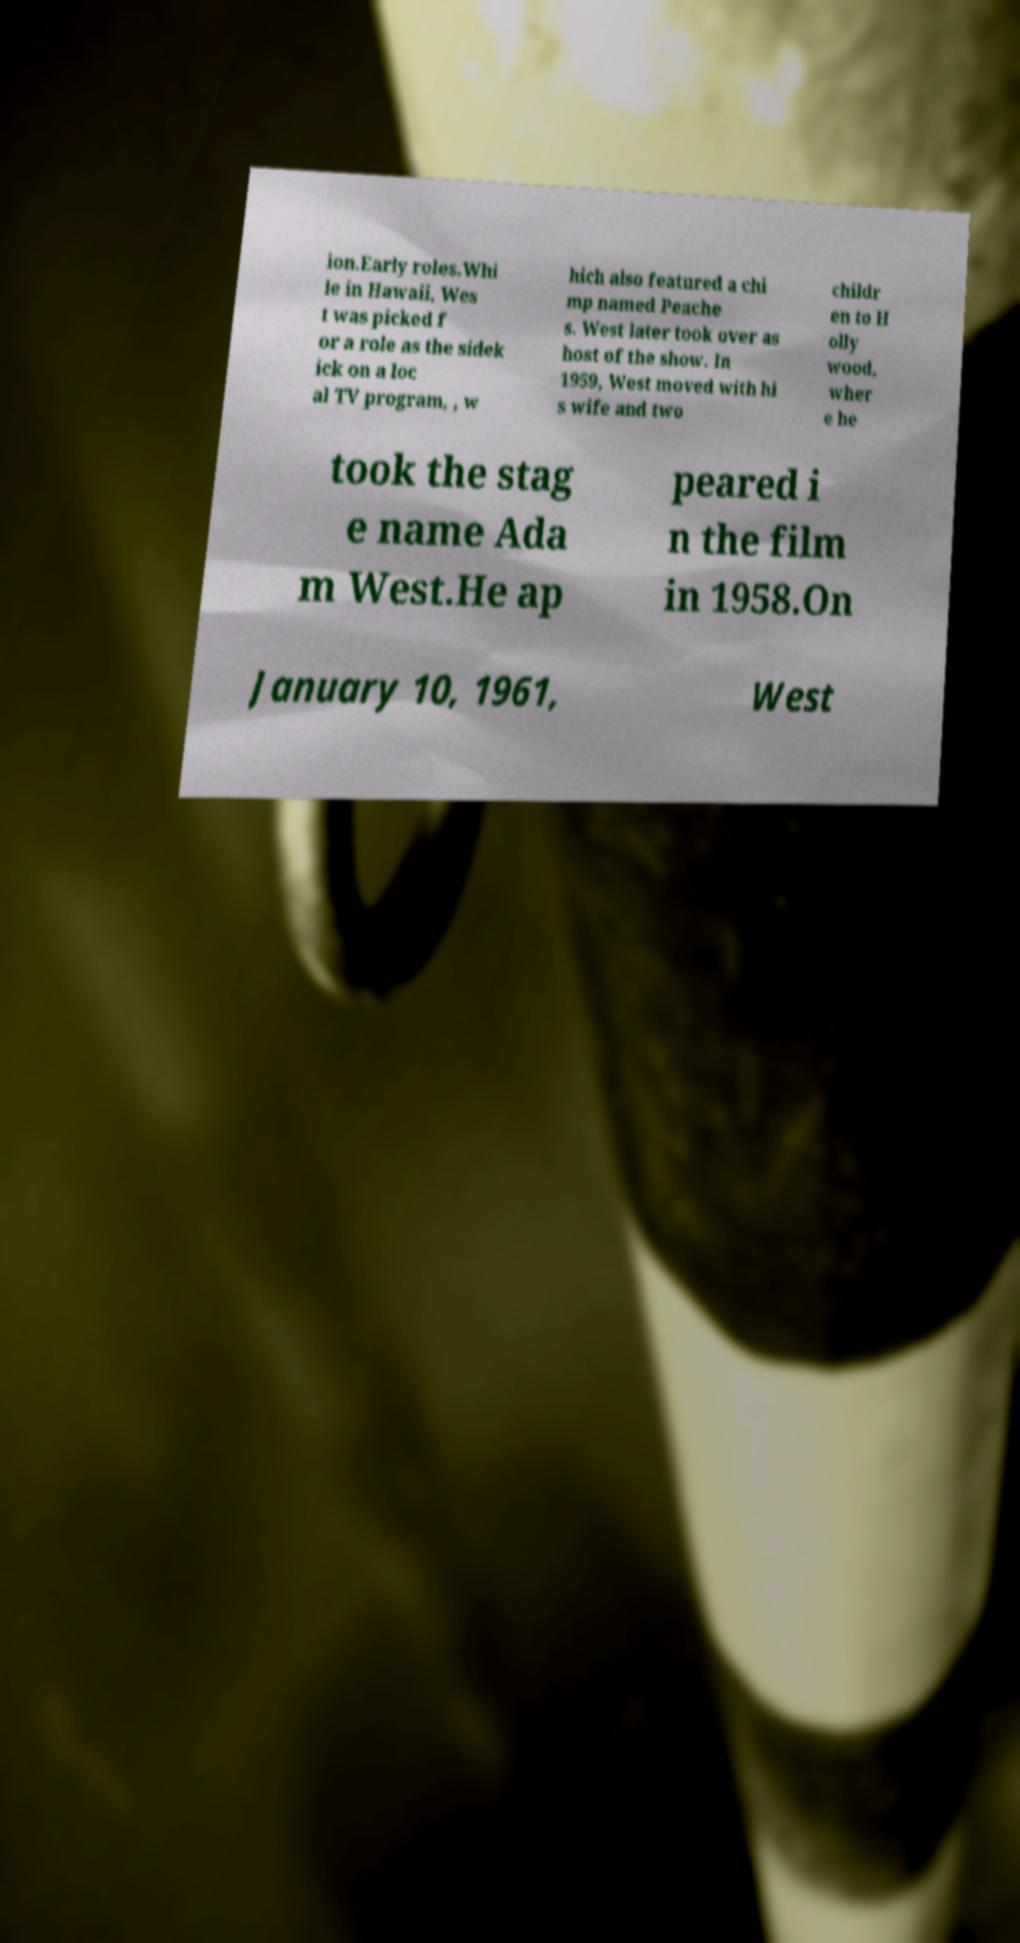Please read and relay the text visible in this image. What does it say? ion.Early roles.Whi le in Hawaii, Wes t was picked f or a role as the sidek ick on a loc al TV program, , w hich also featured a chi mp named Peache s. West later took over as host of the show. In 1959, West moved with hi s wife and two childr en to H olly wood, wher e he took the stag e name Ada m West.He ap peared i n the film in 1958.On January 10, 1961, West 